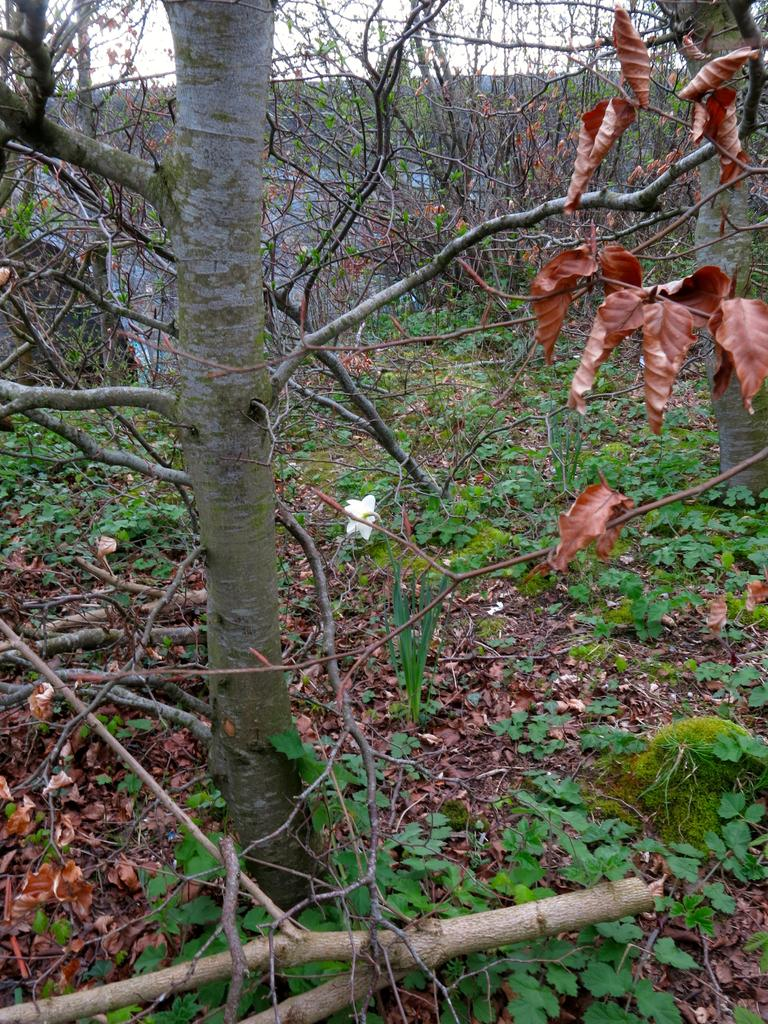What type of vegetation can be seen in the image? There are trees and plants in the image. What is present on the ground among the vegetation? Dry leaves and twigs are visible in the image. What can be seen in the background of the image? There is sky visible in the background of the image. What type of exchange is taking place at the cemetery in the image? There is no cemetery present in the image, and no exchange is taking place. 